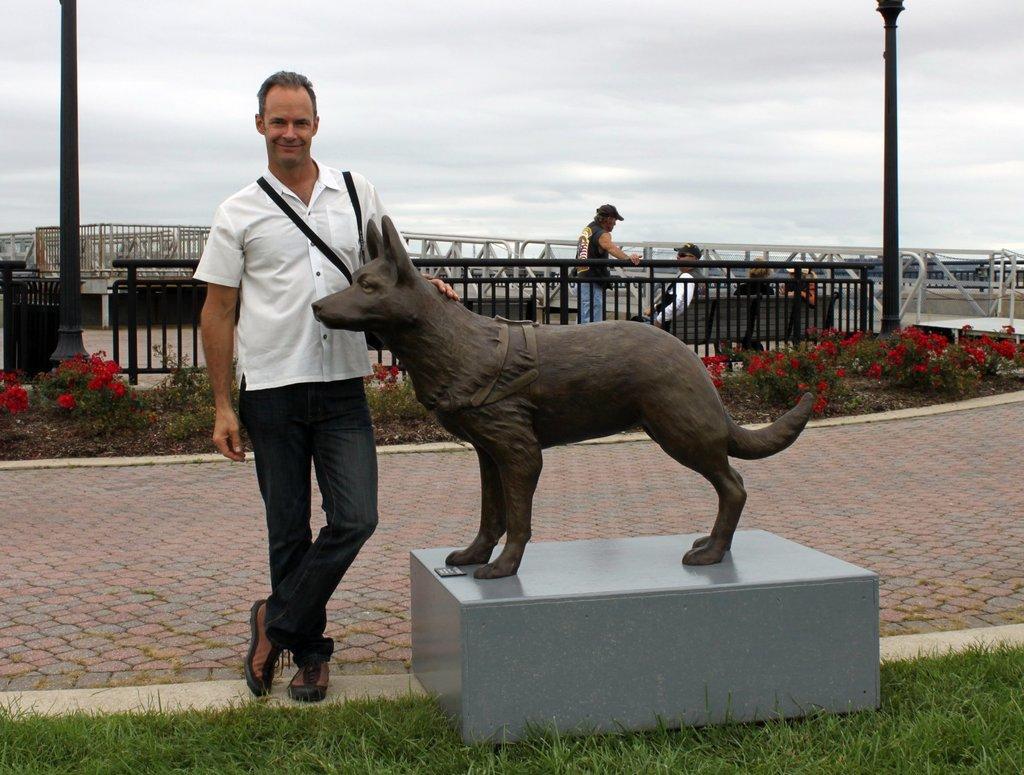Could you give a brief overview of what you see in this image? In this picture outside of the city. There are five people. The two persons are standing and three persons are sitting on a bench. In the center we have a white color shirt person. He is wearing a bag. He is smiling. He is holding a statue. We can see in background sky ,pole and beautiful flowers. 